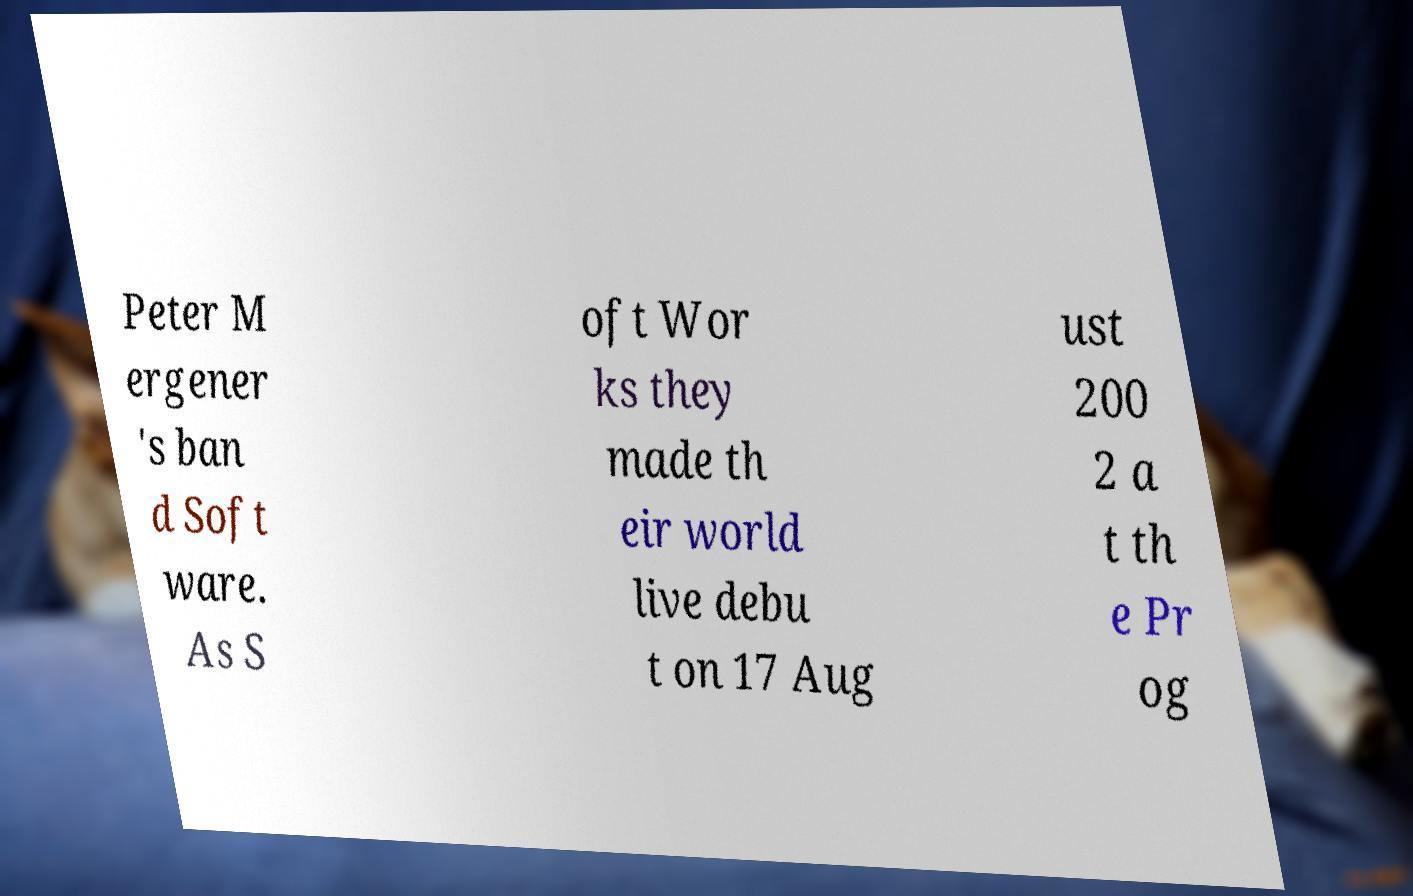I need the written content from this picture converted into text. Can you do that? Peter M ergener 's ban d Soft ware. As S oft Wor ks they made th eir world live debu t on 17 Aug ust 200 2 a t th e Pr og 